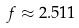<formula> <loc_0><loc_0><loc_500><loc_500>f \approx 2 . 5 1 1</formula> 